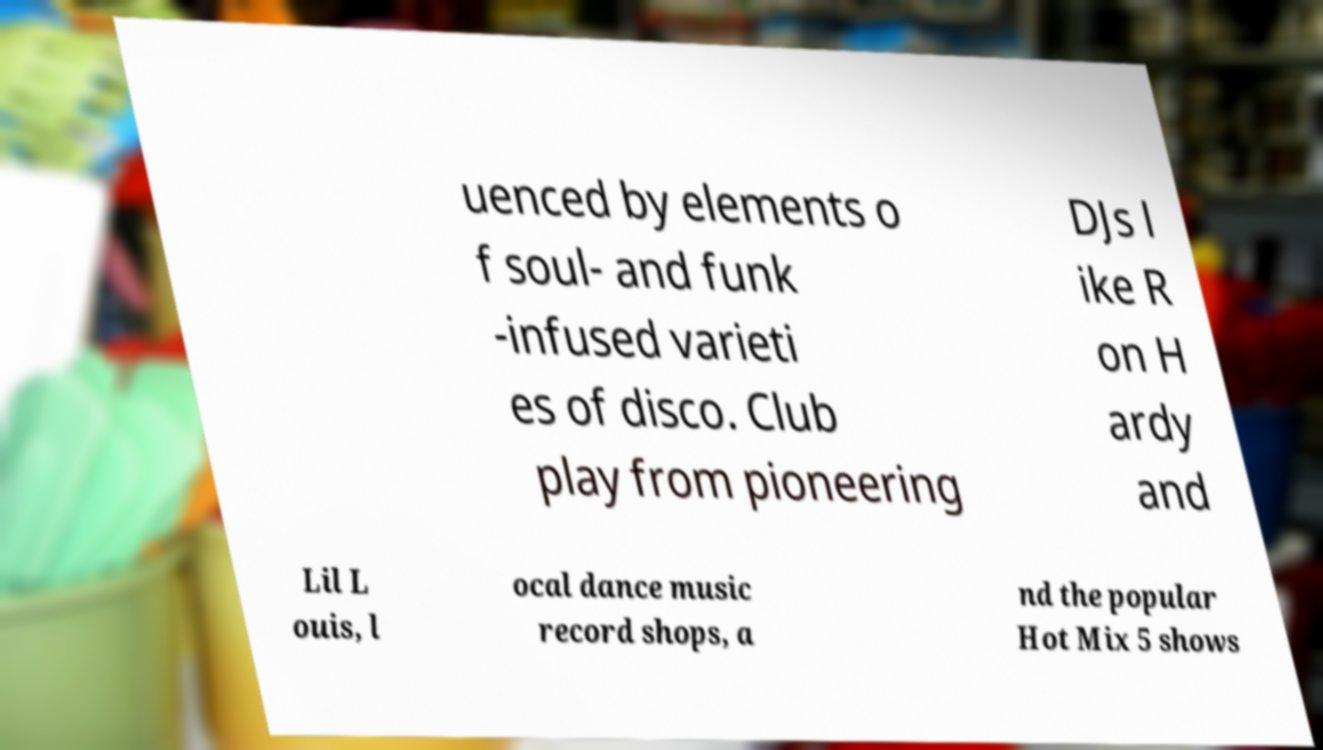Please read and relay the text visible in this image. What does it say? uenced by elements o f soul- and funk -infused varieti es of disco. Club play from pioneering DJs l ike R on H ardy and Lil L ouis, l ocal dance music record shops, a nd the popular Hot Mix 5 shows 